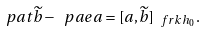<formula> <loc_0><loc_0><loc_500><loc_500>\ p a t \widetilde { b } - \ p a e a = [ a , \widetilde { b } ] _ { \ f r k h _ { 0 } } .</formula> 